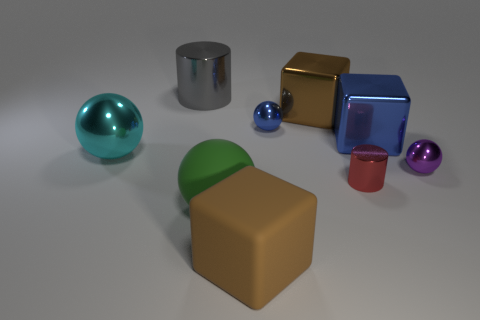Add 1 big brown metallic cubes. How many objects exist? 10 Subtract all red cylinders. How many cylinders are left? 1 Subtract all cylinders. How many objects are left? 7 Subtract all small purple metal balls. How many balls are left? 3 Subtract 0 yellow blocks. How many objects are left? 9 Subtract 3 balls. How many balls are left? 1 Subtract all red cylinders. Subtract all yellow balls. How many cylinders are left? 1 Subtract all blue cubes. How many gray cylinders are left? 1 Subtract all big red things. Subtract all balls. How many objects are left? 5 Add 4 large green objects. How many large green objects are left? 5 